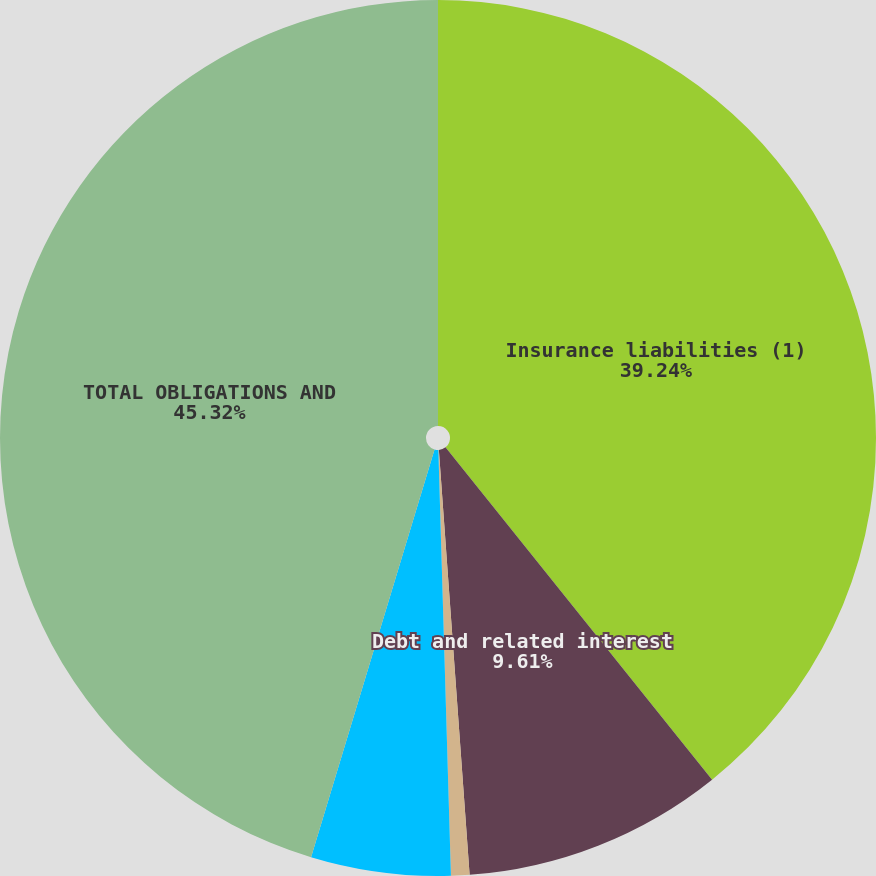Convert chart to OTSL. <chart><loc_0><loc_0><loc_500><loc_500><pie_chart><fcel>Insurance liabilities (1)<fcel>Debt and related interest<fcel>Operating leases<fcel>Pension obligations and<fcel>TOTAL OBLIGATIONS AND<nl><fcel>39.24%<fcel>9.61%<fcel>0.68%<fcel>5.15%<fcel>45.32%<nl></chart> 